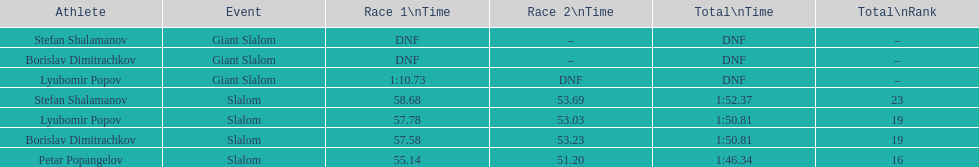Who was last in the slalom overall? Stefan Shalamanov. 